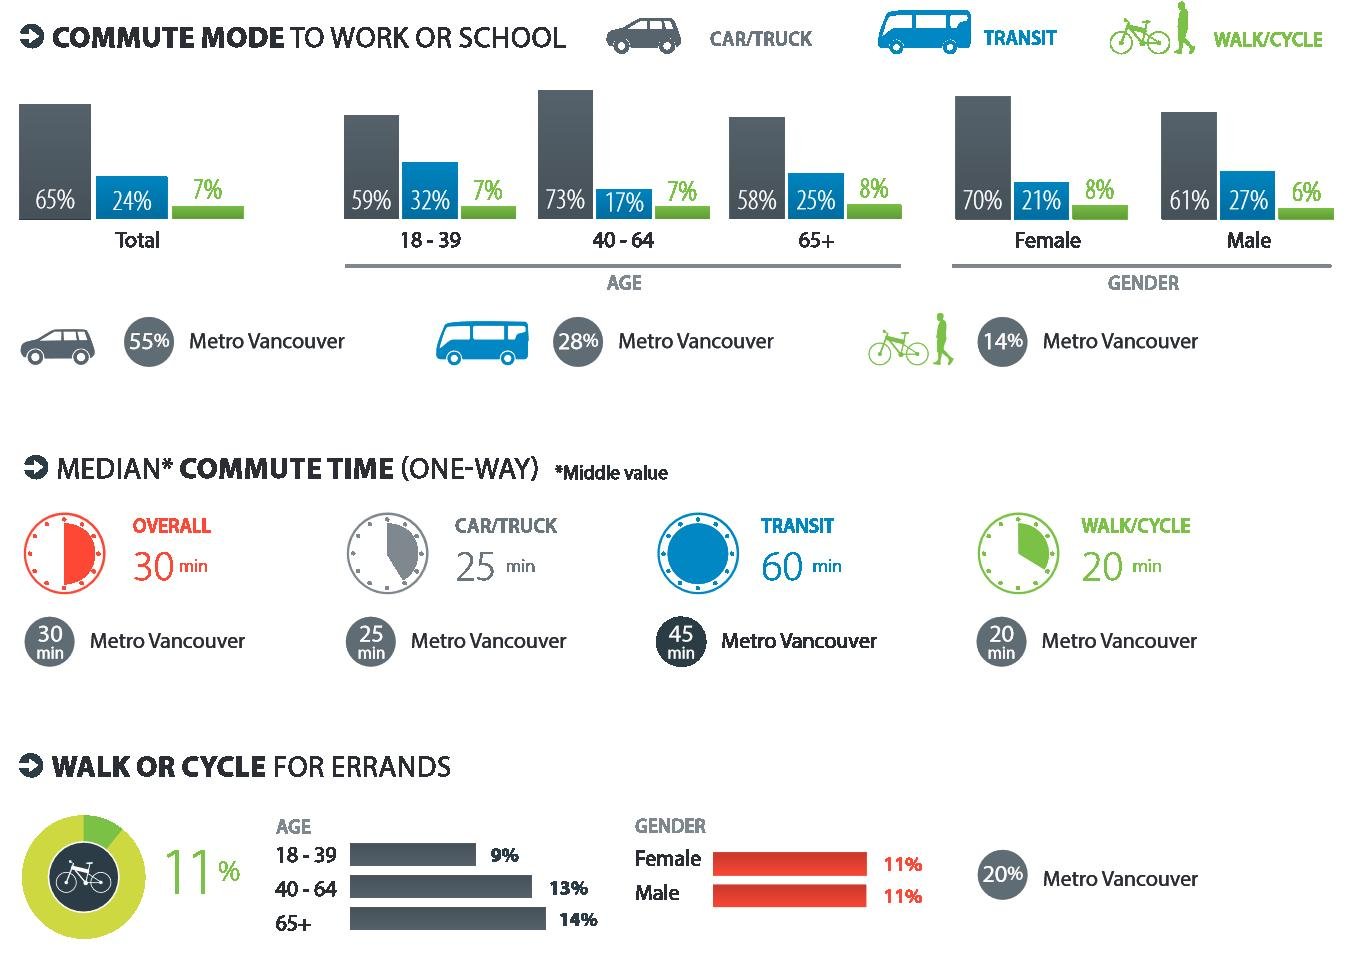Give some essential details in this illustration. According to data, only 7% of people commute to work or school by walking or cycling. In the United States, 64% of senior citizens commute to work or school using a car, truck, walking, or bicycle. According to statistics, 21% of women commute to work or school by transit. According to a recent survey, 70% of women commute to work or school by car or truck. Approximately 27% of men commute to work or school by transit. 